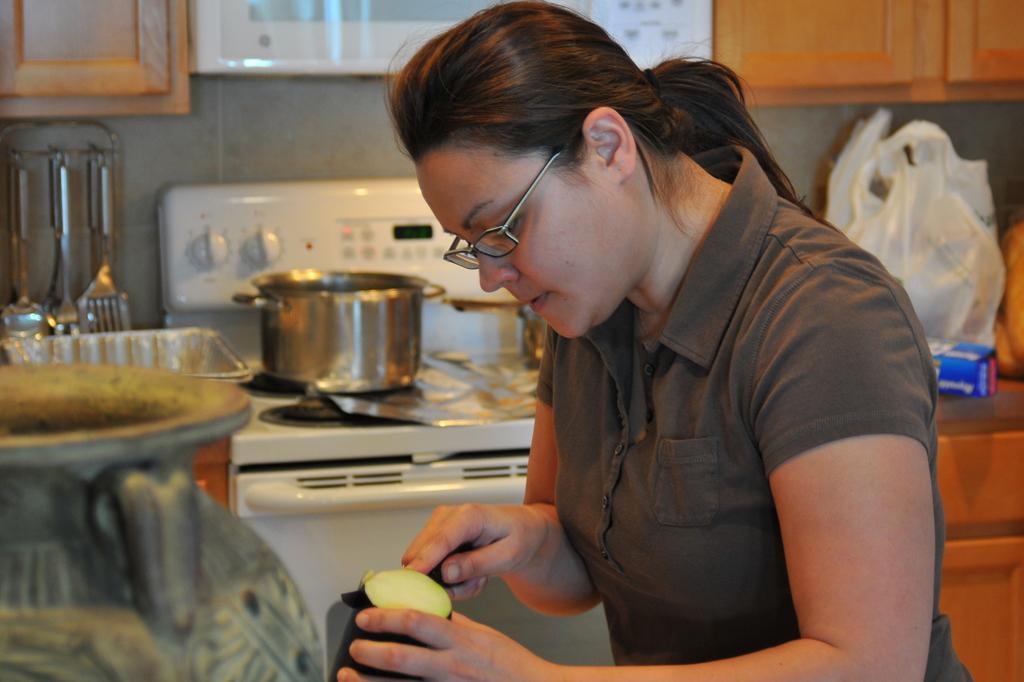Can you describe this image briefly? This seems to be a kitchen. I can see some kitchen objects with a stove on platform and a woman is slicing vegetables in the center of the image. 